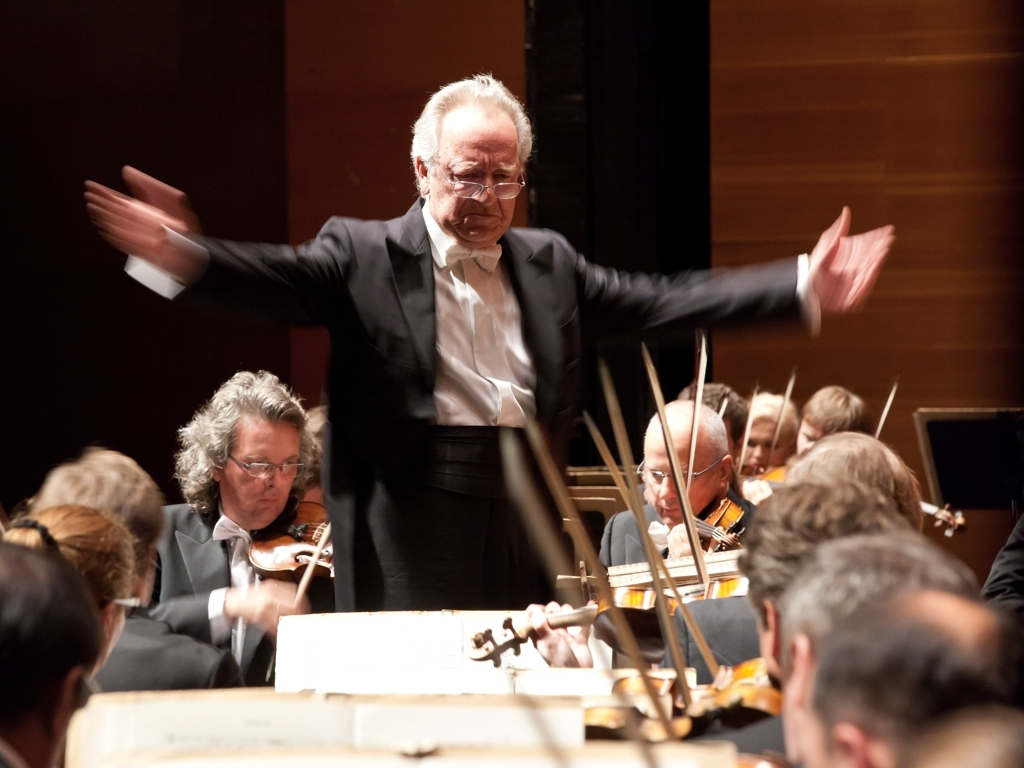What can you say about the lighting and how it affects the atmosphere of the scene? The lighting in the image is concentrated on the conductor, highlighting him as the central figure. The warm, focused lighting appears to create an intimate and intense atmosphere, drawing the audience's attention to his actions and enhancing the drama of the musical performance. 